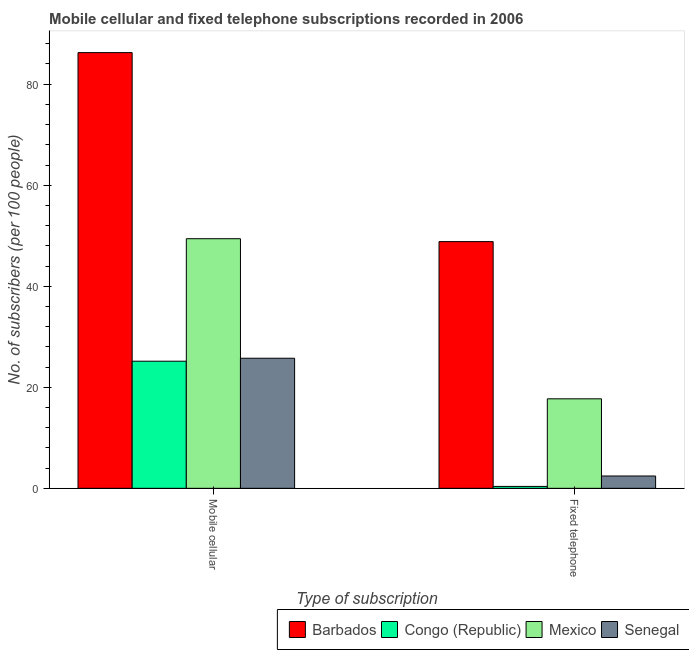How many bars are there on the 1st tick from the left?
Your response must be concise. 4. How many bars are there on the 1st tick from the right?
Ensure brevity in your answer.  4. What is the label of the 1st group of bars from the left?
Your answer should be very brief. Mobile cellular. What is the number of fixed telephone subscribers in Barbados?
Your response must be concise. 48.84. Across all countries, what is the maximum number of fixed telephone subscribers?
Make the answer very short. 48.84. Across all countries, what is the minimum number of mobile cellular subscribers?
Your answer should be compact. 25.16. In which country was the number of fixed telephone subscribers maximum?
Offer a terse response. Barbados. In which country was the number of fixed telephone subscribers minimum?
Your answer should be very brief. Congo (Republic). What is the total number of mobile cellular subscribers in the graph?
Provide a succinct answer. 186.57. What is the difference between the number of mobile cellular subscribers in Barbados and that in Mexico?
Your response must be concise. 36.84. What is the difference between the number of fixed telephone subscribers in Congo (Republic) and the number of mobile cellular subscribers in Mexico?
Your answer should be very brief. -49.03. What is the average number of fixed telephone subscribers per country?
Your answer should be very brief. 17.34. What is the difference between the number of fixed telephone subscribers and number of mobile cellular subscribers in Senegal?
Ensure brevity in your answer.  -23.31. What is the ratio of the number of fixed telephone subscribers in Barbados to that in Mexico?
Offer a very short reply. 2.76. In how many countries, is the number of mobile cellular subscribers greater than the average number of mobile cellular subscribers taken over all countries?
Provide a short and direct response. 2. What does the 1st bar from the left in Fixed telephone represents?
Your response must be concise. Barbados. What does the 1st bar from the right in Mobile cellular represents?
Your response must be concise. Senegal. How many bars are there?
Your response must be concise. 8. Are all the bars in the graph horizontal?
Your answer should be compact. No. How many countries are there in the graph?
Offer a very short reply. 4. What is the difference between two consecutive major ticks on the Y-axis?
Provide a short and direct response. 20. Does the graph contain grids?
Your response must be concise. No. How are the legend labels stacked?
Provide a succinct answer. Horizontal. What is the title of the graph?
Your answer should be compact. Mobile cellular and fixed telephone subscriptions recorded in 2006. Does "Rwanda" appear as one of the legend labels in the graph?
Keep it short and to the point. No. What is the label or title of the X-axis?
Ensure brevity in your answer.  Type of subscription. What is the label or title of the Y-axis?
Ensure brevity in your answer.  No. of subscribers (per 100 people). What is the No. of subscribers (per 100 people) of Barbados in Mobile cellular?
Your response must be concise. 86.25. What is the No. of subscribers (per 100 people) of Congo (Republic) in Mobile cellular?
Give a very brief answer. 25.16. What is the No. of subscribers (per 100 people) of Mexico in Mobile cellular?
Offer a terse response. 49.41. What is the No. of subscribers (per 100 people) of Senegal in Mobile cellular?
Your answer should be compact. 25.75. What is the No. of subscribers (per 100 people) in Barbados in Fixed telephone?
Your response must be concise. 48.84. What is the No. of subscribers (per 100 people) of Congo (Republic) in Fixed telephone?
Provide a succinct answer. 0.38. What is the No. of subscribers (per 100 people) in Mexico in Fixed telephone?
Provide a short and direct response. 17.71. What is the No. of subscribers (per 100 people) of Senegal in Fixed telephone?
Your answer should be compact. 2.44. Across all Type of subscription, what is the maximum No. of subscribers (per 100 people) in Barbados?
Make the answer very short. 86.25. Across all Type of subscription, what is the maximum No. of subscribers (per 100 people) of Congo (Republic)?
Provide a succinct answer. 25.16. Across all Type of subscription, what is the maximum No. of subscribers (per 100 people) of Mexico?
Offer a very short reply. 49.41. Across all Type of subscription, what is the maximum No. of subscribers (per 100 people) of Senegal?
Offer a very short reply. 25.75. Across all Type of subscription, what is the minimum No. of subscribers (per 100 people) of Barbados?
Ensure brevity in your answer.  48.84. Across all Type of subscription, what is the minimum No. of subscribers (per 100 people) in Congo (Republic)?
Provide a succinct answer. 0.38. Across all Type of subscription, what is the minimum No. of subscribers (per 100 people) in Mexico?
Your answer should be very brief. 17.71. Across all Type of subscription, what is the minimum No. of subscribers (per 100 people) in Senegal?
Your response must be concise. 2.44. What is the total No. of subscribers (per 100 people) of Barbados in the graph?
Keep it short and to the point. 135.09. What is the total No. of subscribers (per 100 people) of Congo (Republic) in the graph?
Provide a short and direct response. 25.54. What is the total No. of subscribers (per 100 people) of Mexico in the graph?
Ensure brevity in your answer.  67.12. What is the total No. of subscribers (per 100 people) in Senegal in the graph?
Keep it short and to the point. 28.19. What is the difference between the No. of subscribers (per 100 people) in Barbados in Mobile cellular and that in Fixed telephone?
Give a very brief answer. 37.41. What is the difference between the No. of subscribers (per 100 people) of Congo (Republic) in Mobile cellular and that in Fixed telephone?
Provide a succinct answer. 24.78. What is the difference between the No. of subscribers (per 100 people) of Mexico in Mobile cellular and that in Fixed telephone?
Keep it short and to the point. 31.69. What is the difference between the No. of subscribers (per 100 people) of Senegal in Mobile cellular and that in Fixed telephone?
Provide a succinct answer. 23.31. What is the difference between the No. of subscribers (per 100 people) of Barbados in Mobile cellular and the No. of subscribers (per 100 people) of Congo (Republic) in Fixed telephone?
Your answer should be compact. 85.87. What is the difference between the No. of subscribers (per 100 people) of Barbados in Mobile cellular and the No. of subscribers (per 100 people) of Mexico in Fixed telephone?
Your answer should be very brief. 68.53. What is the difference between the No. of subscribers (per 100 people) of Barbados in Mobile cellular and the No. of subscribers (per 100 people) of Senegal in Fixed telephone?
Provide a succinct answer. 83.81. What is the difference between the No. of subscribers (per 100 people) in Congo (Republic) in Mobile cellular and the No. of subscribers (per 100 people) in Mexico in Fixed telephone?
Ensure brevity in your answer.  7.45. What is the difference between the No. of subscribers (per 100 people) of Congo (Republic) in Mobile cellular and the No. of subscribers (per 100 people) of Senegal in Fixed telephone?
Provide a succinct answer. 22.72. What is the difference between the No. of subscribers (per 100 people) of Mexico in Mobile cellular and the No. of subscribers (per 100 people) of Senegal in Fixed telephone?
Ensure brevity in your answer.  46.97. What is the average No. of subscribers (per 100 people) of Barbados per Type of subscription?
Provide a succinct answer. 67.54. What is the average No. of subscribers (per 100 people) of Congo (Republic) per Type of subscription?
Ensure brevity in your answer.  12.77. What is the average No. of subscribers (per 100 people) of Mexico per Type of subscription?
Offer a very short reply. 33.56. What is the average No. of subscribers (per 100 people) in Senegal per Type of subscription?
Give a very brief answer. 14.09. What is the difference between the No. of subscribers (per 100 people) of Barbados and No. of subscribers (per 100 people) of Congo (Republic) in Mobile cellular?
Provide a short and direct response. 61.09. What is the difference between the No. of subscribers (per 100 people) in Barbados and No. of subscribers (per 100 people) in Mexico in Mobile cellular?
Offer a very short reply. 36.84. What is the difference between the No. of subscribers (per 100 people) of Barbados and No. of subscribers (per 100 people) of Senegal in Mobile cellular?
Keep it short and to the point. 60.5. What is the difference between the No. of subscribers (per 100 people) of Congo (Republic) and No. of subscribers (per 100 people) of Mexico in Mobile cellular?
Your answer should be compact. -24.25. What is the difference between the No. of subscribers (per 100 people) of Congo (Republic) and No. of subscribers (per 100 people) of Senegal in Mobile cellular?
Offer a very short reply. -0.59. What is the difference between the No. of subscribers (per 100 people) in Mexico and No. of subscribers (per 100 people) in Senegal in Mobile cellular?
Provide a succinct answer. 23.66. What is the difference between the No. of subscribers (per 100 people) of Barbados and No. of subscribers (per 100 people) of Congo (Republic) in Fixed telephone?
Keep it short and to the point. 48.46. What is the difference between the No. of subscribers (per 100 people) of Barbados and No. of subscribers (per 100 people) of Mexico in Fixed telephone?
Provide a short and direct response. 31.12. What is the difference between the No. of subscribers (per 100 people) of Barbados and No. of subscribers (per 100 people) of Senegal in Fixed telephone?
Your answer should be very brief. 46.4. What is the difference between the No. of subscribers (per 100 people) of Congo (Republic) and No. of subscribers (per 100 people) of Mexico in Fixed telephone?
Make the answer very short. -17.34. What is the difference between the No. of subscribers (per 100 people) in Congo (Republic) and No. of subscribers (per 100 people) in Senegal in Fixed telephone?
Make the answer very short. -2.06. What is the difference between the No. of subscribers (per 100 people) of Mexico and No. of subscribers (per 100 people) of Senegal in Fixed telephone?
Make the answer very short. 15.28. What is the ratio of the No. of subscribers (per 100 people) in Barbados in Mobile cellular to that in Fixed telephone?
Offer a very short reply. 1.77. What is the ratio of the No. of subscribers (per 100 people) in Congo (Republic) in Mobile cellular to that in Fixed telephone?
Provide a short and direct response. 66.71. What is the ratio of the No. of subscribers (per 100 people) in Mexico in Mobile cellular to that in Fixed telephone?
Give a very brief answer. 2.79. What is the ratio of the No. of subscribers (per 100 people) of Senegal in Mobile cellular to that in Fixed telephone?
Provide a succinct answer. 10.56. What is the difference between the highest and the second highest No. of subscribers (per 100 people) in Barbados?
Offer a terse response. 37.41. What is the difference between the highest and the second highest No. of subscribers (per 100 people) in Congo (Republic)?
Provide a short and direct response. 24.78. What is the difference between the highest and the second highest No. of subscribers (per 100 people) in Mexico?
Provide a succinct answer. 31.69. What is the difference between the highest and the second highest No. of subscribers (per 100 people) of Senegal?
Ensure brevity in your answer.  23.31. What is the difference between the highest and the lowest No. of subscribers (per 100 people) in Barbados?
Make the answer very short. 37.41. What is the difference between the highest and the lowest No. of subscribers (per 100 people) in Congo (Republic)?
Make the answer very short. 24.78. What is the difference between the highest and the lowest No. of subscribers (per 100 people) in Mexico?
Give a very brief answer. 31.69. What is the difference between the highest and the lowest No. of subscribers (per 100 people) of Senegal?
Ensure brevity in your answer.  23.31. 